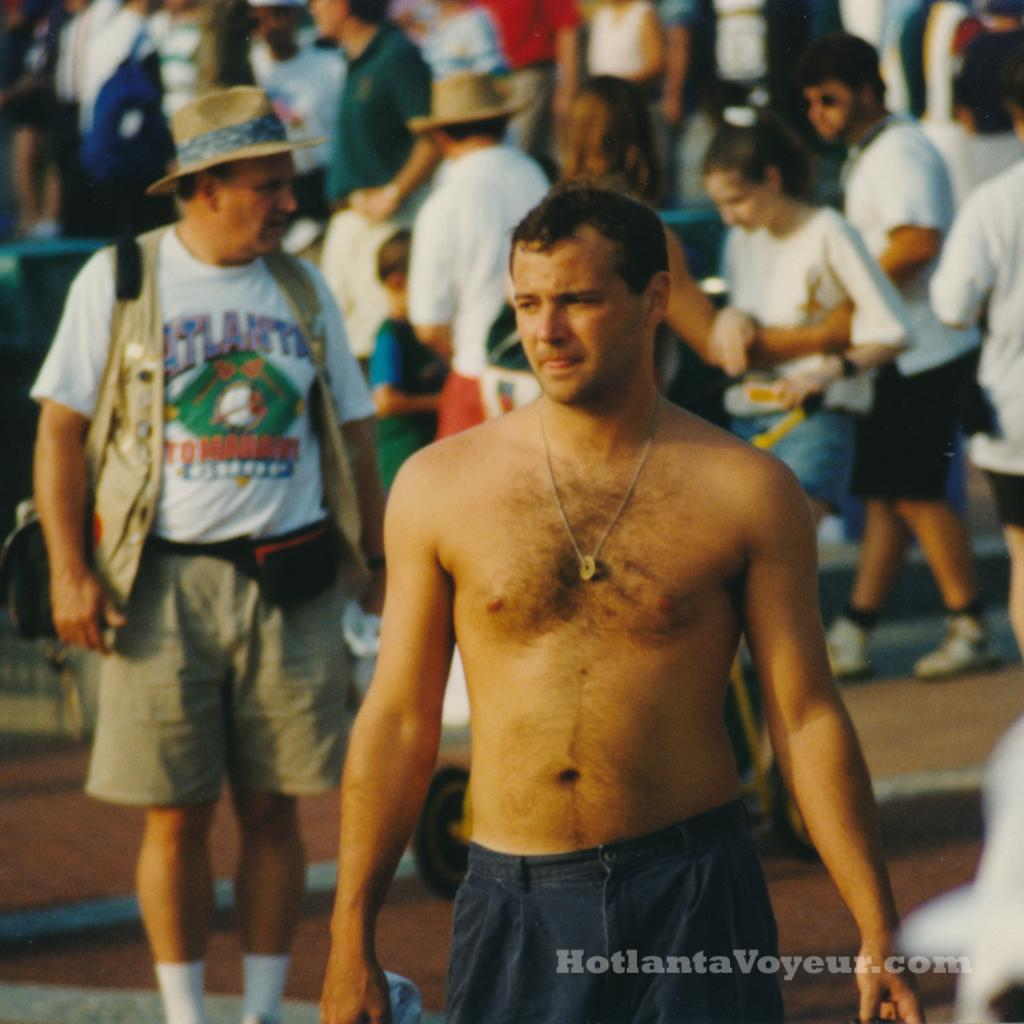Provide a one-sentence caption for the provided image. A group of people on a street with a man wearing a tshirt that says Atlanta. 